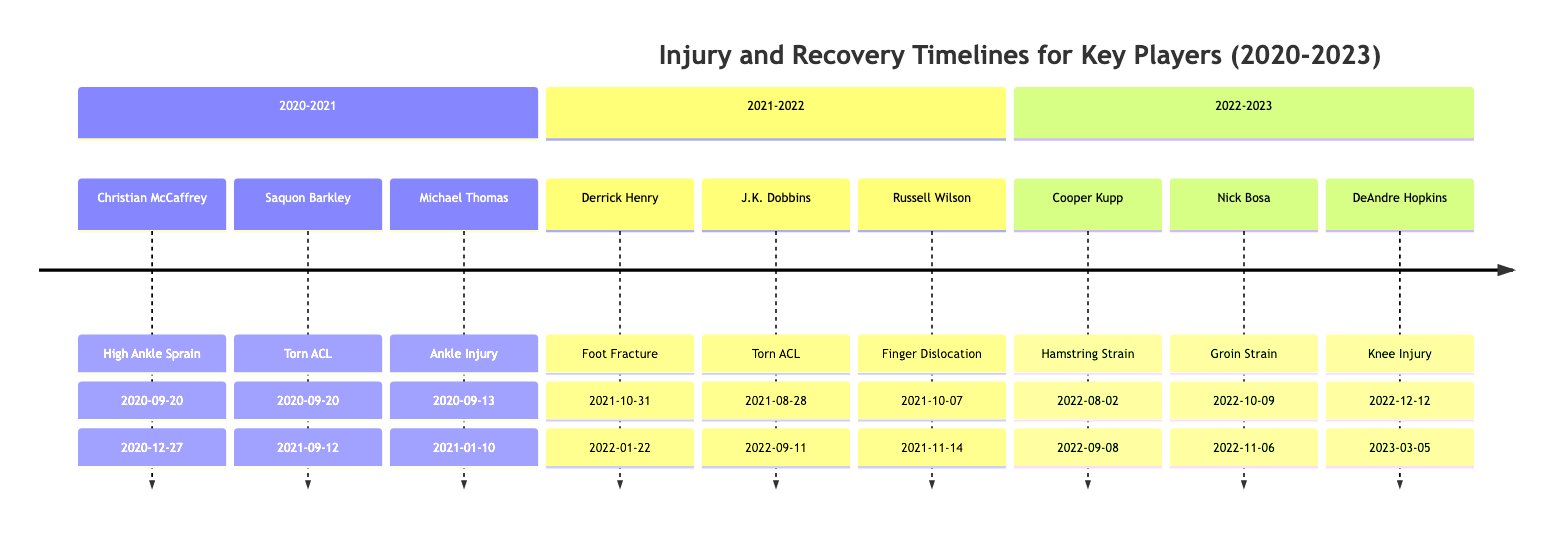what injury did Christian McCaffrey suffer in the 2020-2021 season? The diagram indicates that Christian McCaffrey suffered from a High Ankle Sprain during the 2020-2021 season. This can be directly found under the 2020-2021 section in the timeline.
Answer: High Ankle Sprain how long did Saquon Barkley miss due to his injury? Saquon Barkley missed a total of 15 games due to his Torn ACL injury. This information is clearly listed next to his injury details in the 2020-2021 section.
Answer: 15 games which player returned from injury the earliest in the 2021-2022 season? By evaluating the return dates for players in the 2021-2022 season, Russell Wilson returned the earliest on November 14, 2021, compared to others who returned later in January or September 2022.
Answer: Russell Wilson what is the long-term risk for DeAndre Hopkins due to his knee injury? The long-term risk associated with DeAndre Hopkins’s knee injury is categorized as High, as indicated in the diagram under the 2022-2023 season.
Answer: High which player from the 2021-2022 season had a foot injury? Derrick Henry is the player from the 2021-2022 season who had a Foot Fracture. This is mentioned in the timeline corresponding to his injury details.
Answer: Derrick Henry how many players had injuries in the 2020-2021 season? The diagram shows three players with injuries in the 2020-2021 season: Christian McCaffrey, Saquon Barkley, and Michael Thomas. Counting these names confirms that there are three players listed.
Answer: 3 what are the names of the players with torn ACL injuries over the three seasons? Inspecting the timeline reveals that both Saquon Barkley (2020-2021 season) and J.K. Dobbins (2021-2022 season) suffered torn ACL injuries, thus the names would be Saquon Barkley and J.K. Dobbins.
Answer: Saquon Barkley, J.K. Dobbins in which season did Cooper Kupp get injured? By looking at the diagram, Cooper Kupp was injured in the 2022-2023 season, as stated in the timeline section that details his injury occurrence.
Answer: 2022-2023 how many games did Nick Bosa miss due to his groin strain? The information specific to Nick Bosa shows that he missed a total of 4 games due to his Groin Strain injury, which can be found adjacent to his injury details in the timeline.
Answer: 4 games 